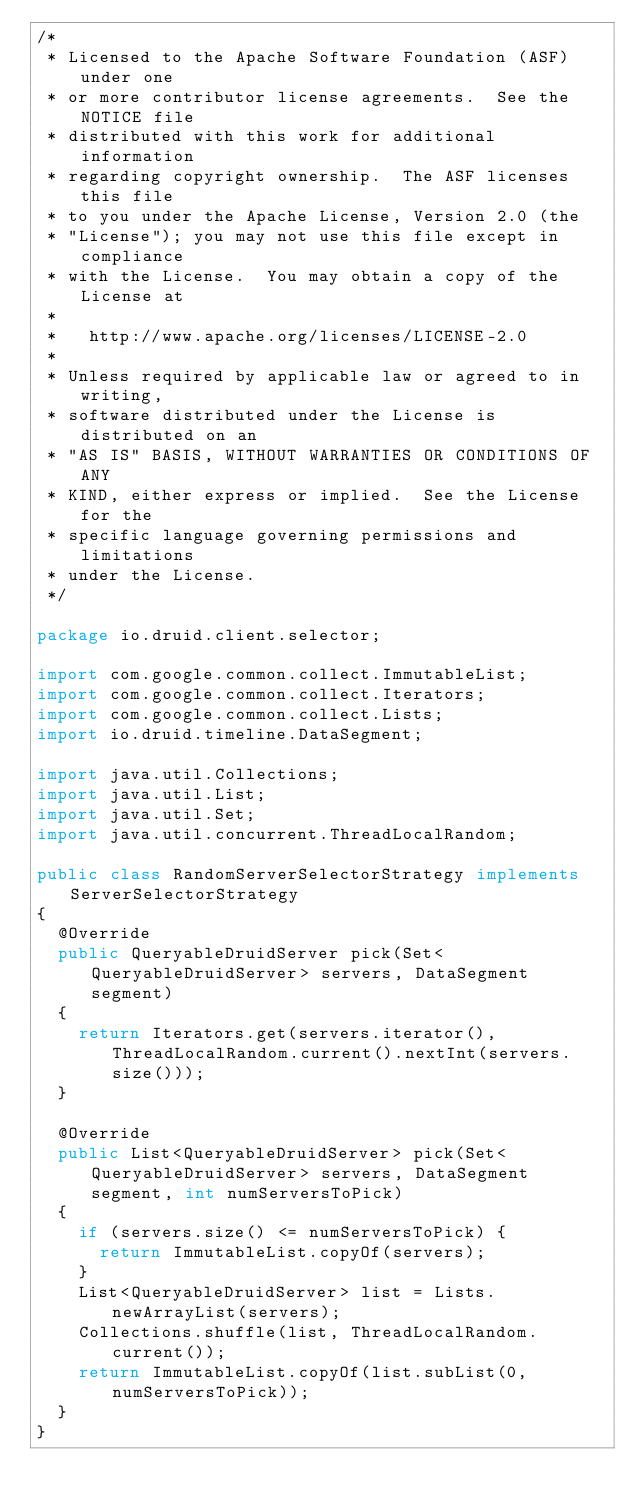Convert code to text. <code><loc_0><loc_0><loc_500><loc_500><_Java_>/*
 * Licensed to the Apache Software Foundation (ASF) under one
 * or more contributor license agreements.  See the NOTICE file
 * distributed with this work for additional information
 * regarding copyright ownership.  The ASF licenses this file
 * to you under the Apache License, Version 2.0 (the
 * "License"); you may not use this file except in compliance
 * with the License.  You may obtain a copy of the License at
 *
 *   http://www.apache.org/licenses/LICENSE-2.0
 *
 * Unless required by applicable law or agreed to in writing,
 * software distributed under the License is distributed on an
 * "AS IS" BASIS, WITHOUT WARRANTIES OR CONDITIONS OF ANY
 * KIND, either express or implied.  See the License for the
 * specific language governing permissions and limitations
 * under the License.
 */

package io.druid.client.selector;

import com.google.common.collect.ImmutableList;
import com.google.common.collect.Iterators;
import com.google.common.collect.Lists;
import io.druid.timeline.DataSegment;

import java.util.Collections;
import java.util.List;
import java.util.Set;
import java.util.concurrent.ThreadLocalRandom;

public class RandomServerSelectorStrategy implements ServerSelectorStrategy
{
  @Override
  public QueryableDruidServer pick(Set<QueryableDruidServer> servers, DataSegment segment)
  {
    return Iterators.get(servers.iterator(), ThreadLocalRandom.current().nextInt(servers.size()));
  }

  @Override
  public List<QueryableDruidServer> pick(Set<QueryableDruidServer> servers, DataSegment segment, int numServersToPick)
  {
    if (servers.size() <= numServersToPick) {
      return ImmutableList.copyOf(servers);
    }
    List<QueryableDruidServer> list = Lists.newArrayList(servers);
    Collections.shuffle(list, ThreadLocalRandom.current());
    return ImmutableList.copyOf(list.subList(0, numServersToPick));
  }
}
</code> 